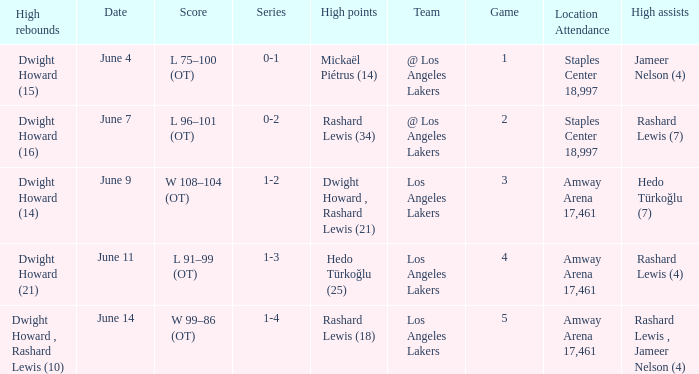What is Team, when High Assists is "Rashard Lewis (4)"? Los Angeles Lakers. 